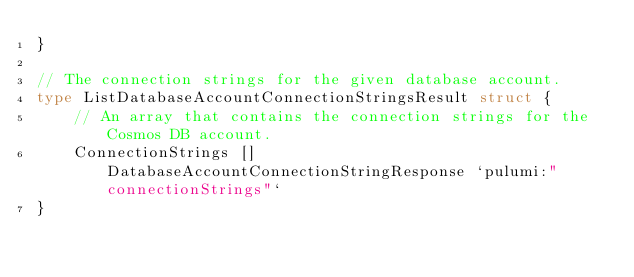<code> <loc_0><loc_0><loc_500><loc_500><_Go_>}

// The connection strings for the given database account.
type ListDatabaseAccountConnectionStringsResult struct {
	// An array that contains the connection strings for the Cosmos DB account.
	ConnectionStrings []DatabaseAccountConnectionStringResponse `pulumi:"connectionStrings"`
}
</code> 